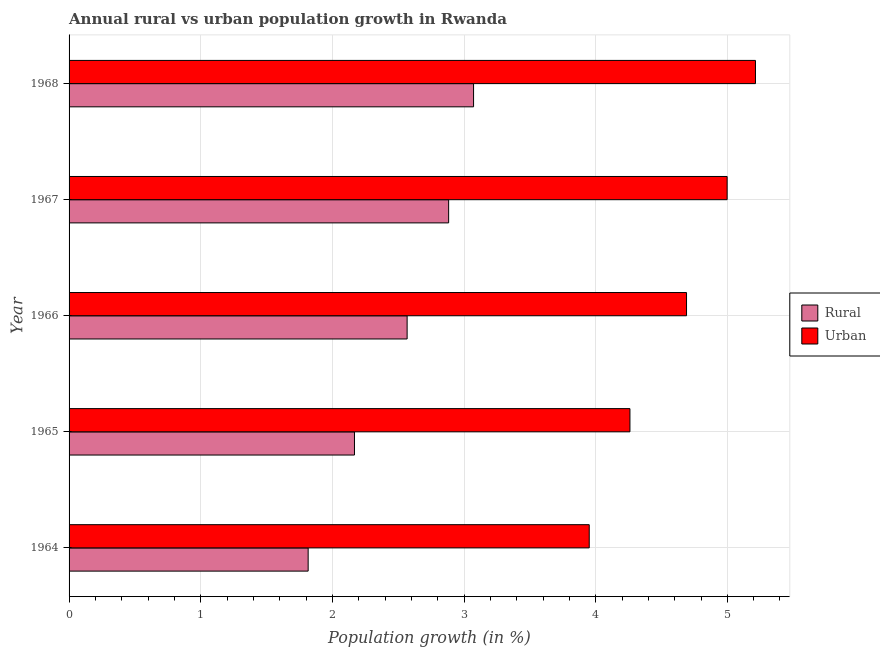Are the number of bars per tick equal to the number of legend labels?
Give a very brief answer. Yes. Are the number of bars on each tick of the Y-axis equal?
Offer a terse response. Yes. What is the label of the 2nd group of bars from the top?
Make the answer very short. 1967. What is the urban population growth in 1966?
Make the answer very short. 4.69. Across all years, what is the maximum rural population growth?
Your response must be concise. 3.07. Across all years, what is the minimum urban population growth?
Offer a terse response. 3.95. In which year was the urban population growth maximum?
Give a very brief answer. 1968. In which year was the urban population growth minimum?
Your response must be concise. 1964. What is the total urban population growth in the graph?
Your answer should be very brief. 23.11. What is the difference between the rural population growth in 1965 and that in 1968?
Ensure brevity in your answer.  -0.91. What is the difference between the urban population growth in 1964 and the rural population growth in 1966?
Your answer should be compact. 1.38. What is the average rural population growth per year?
Make the answer very short. 2.5. In the year 1968, what is the difference between the rural population growth and urban population growth?
Make the answer very short. -2.14. Is the difference between the rural population growth in 1964 and 1967 greater than the difference between the urban population growth in 1964 and 1967?
Provide a succinct answer. No. What is the difference between the highest and the second highest urban population growth?
Keep it short and to the point. 0.21. What is the difference between the highest and the lowest urban population growth?
Provide a succinct answer. 1.26. In how many years, is the rural population growth greater than the average rural population growth taken over all years?
Your answer should be compact. 3. What does the 2nd bar from the top in 1965 represents?
Offer a terse response. Rural. What does the 1st bar from the bottom in 1968 represents?
Keep it short and to the point. Rural. How many bars are there?
Your response must be concise. 10. Are all the bars in the graph horizontal?
Keep it short and to the point. Yes. How many years are there in the graph?
Make the answer very short. 5. Does the graph contain any zero values?
Your answer should be very brief. No. Does the graph contain grids?
Provide a succinct answer. Yes. Where does the legend appear in the graph?
Provide a succinct answer. Center right. What is the title of the graph?
Ensure brevity in your answer.  Annual rural vs urban population growth in Rwanda. Does "Lower secondary education" appear as one of the legend labels in the graph?
Offer a very short reply. No. What is the label or title of the X-axis?
Make the answer very short. Population growth (in %). What is the Population growth (in %) of Rural in 1964?
Provide a short and direct response. 1.82. What is the Population growth (in %) in Urban  in 1964?
Provide a short and direct response. 3.95. What is the Population growth (in %) in Rural in 1965?
Provide a succinct answer. 2.17. What is the Population growth (in %) in Urban  in 1965?
Provide a succinct answer. 4.26. What is the Population growth (in %) in Rural in 1966?
Make the answer very short. 2.57. What is the Population growth (in %) of Urban  in 1966?
Your answer should be very brief. 4.69. What is the Population growth (in %) in Rural in 1967?
Your answer should be very brief. 2.88. What is the Population growth (in %) of Urban  in 1967?
Your answer should be compact. 5. What is the Population growth (in %) of Rural in 1968?
Your response must be concise. 3.07. What is the Population growth (in %) of Urban  in 1968?
Keep it short and to the point. 5.21. Across all years, what is the maximum Population growth (in %) in Rural?
Keep it short and to the point. 3.07. Across all years, what is the maximum Population growth (in %) of Urban ?
Make the answer very short. 5.21. Across all years, what is the minimum Population growth (in %) of Rural?
Offer a terse response. 1.82. Across all years, what is the minimum Population growth (in %) in Urban ?
Offer a terse response. 3.95. What is the total Population growth (in %) in Rural in the graph?
Make the answer very short. 12.51. What is the total Population growth (in %) in Urban  in the graph?
Provide a short and direct response. 23.11. What is the difference between the Population growth (in %) of Rural in 1964 and that in 1965?
Offer a very short reply. -0.35. What is the difference between the Population growth (in %) in Urban  in 1964 and that in 1965?
Keep it short and to the point. -0.31. What is the difference between the Population growth (in %) in Rural in 1964 and that in 1966?
Your answer should be compact. -0.75. What is the difference between the Population growth (in %) of Urban  in 1964 and that in 1966?
Give a very brief answer. -0.74. What is the difference between the Population growth (in %) in Rural in 1964 and that in 1967?
Make the answer very short. -1.07. What is the difference between the Population growth (in %) of Urban  in 1964 and that in 1967?
Make the answer very short. -1.05. What is the difference between the Population growth (in %) of Rural in 1964 and that in 1968?
Your response must be concise. -1.26. What is the difference between the Population growth (in %) of Urban  in 1964 and that in 1968?
Your response must be concise. -1.26. What is the difference between the Population growth (in %) in Urban  in 1965 and that in 1966?
Make the answer very short. -0.43. What is the difference between the Population growth (in %) in Rural in 1965 and that in 1967?
Make the answer very short. -0.72. What is the difference between the Population growth (in %) of Urban  in 1965 and that in 1967?
Your response must be concise. -0.74. What is the difference between the Population growth (in %) of Rural in 1965 and that in 1968?
Your response must be concise. -0.9. What is the difference between the Population growth (in %) of Urban  in 1965 and that in 1968?
Offer a very short reply. -0.95. What is the difference between the Population growth (in %) in Rural in 1966 and that in 1967?
Give a very brief answer. -0.32. What is the difference between the Population growth (in %) of Urban  in 1966 and that in 1967?
Your response must be concise. -0.31. What is the difference between the Population growth (in %) in Rural in 1966 and that in 1968?
Provide a succinct answer. -0.5. What is the difference between the Population growth (in %) of Urban  in 1966 and that in 1968?
Make the answer very short. -0.52. What is the difference between the Population growth (in %) of Rural in 1967 and that in 1968?
Make the answer very short. -0.19. What is the difference between the Population growth (in %) of Urban  in 1967 and that in 1968?
Your answer should be very brief. -0.22. What is the difference between the Population growth (in %) in Rural in 1964 and the Population growth (in %) in Urban  in 1965?
Offer a terse response. -2.44. What is the difference between the Population growth (in %) of Rural in 1964 and the Population growth (in %) of Urban  in 1966?
Make the answer very short. -2.87. What is the difference between the Population growth (in %) in Rural in 1964 and the Population growth (in %) in Urban  in 1967?
Provide a succinct answer. -3.18. What is the difference between the Population growth (in %) of Rural in 1964 and the Population growth (in %) of Urban  in 1968?
Your answer should be very brief. -3.4. What is the difference between the Population growth (in %) of Rural in 1965 and the Population growth (in %) of Urban  in 1966?
Provide a succinct answer. -2.52. What is the difference between the Population growth (in %) of Rural in 1965 and the Population growth (in %) of Urban  in 1967?
Make the answer very short. -2.83. What is the difference between the Population growth (in %) of Rural in 1965 and the Population growth (in %) of Urban  in 1968?
Ensure brevity in your answer.  -3.05. What is the difference between the Population growth (in %) in Rural in 1966 and the Population growth (in %) in Urban  in 1967?
Your response must be concise. -2.43. What is the difference between the Population growth (in %) in Rural in 1966 and the Population growth (in %) in Urban  in 1968?
Offer a terse response. -2.65. What is the difference between the Population growth (in %) in Rural in 1967 and the Population growth (in %) in Urban  in 1968?
Make the answer very short. -2.33. What is the average Population growth (in %) of Rural per year?
Offer a very short reply. 2.5. What is the average Population growth (in %) of Urban  per year?
Provide a short and direct response. 4.62. In the year 1964, what is the difference between the Population growth (in %) of Rural and Population growth (in %) of Urban ?
Your answer should be compact. -2.14. In the year 1965, what is the difference between the Population growth (in %) in Rural and Population growth (in %) in Urban ?
Give a very brief answer. -2.09. In the year 1966, what is the difference between the Population growth (in %) of Rural and Population growth (in %) of Urban ?
Give a very brief answer. -2.12. In the year 1967, what is the difference between the Population growth (in %) in Rural and Population growth (in %) in Urban ?
Give a very brief answer. -2.12. In the year 1968, what is the difference between the Population growth (in %) of Rural and Population growth (in %) of Urban ?
Your answer should be compact. -2.14. What is the ratio of the Population growth (in %) of Rural in 1964 to that in 1965?
Make the answer very short. 0.84. What is the ratio of the Population growth (in %) in Urban  in 1964 to that in 1965?
Give a very brief answer. 0.93. What is the ratio of the Population growth (in %) of Rural in 1964 to that in 1966?
Your response must be concise. 0.71. What is the ratio of the Population growth (in %) of Urban  in 1964 to that in 1966?
Offer a very short reply. 0.84. What is the ratio of the Population growth (in %) in Rural in 1964 to that in 1967?
Give a very brief answer. 0.63. What is the ratio of the Population growth (in %) of Urban  in 1964 to that in 1967?
Provide a succinct answer. 0.79. What is the ratio of the Population growth (in %) in Rural in 1964 to that in 1968?
Your answer should be very brief. 0.59. What is the ratio of the Population growth (in %) of Urban  in 1964 to that in 1968?
Give a very brief answer. 0.76. What is the ratio of the Population growth (in %) in Rural in 1965 to that in 1966?
Provide a succinct answer. 0.84. What is the ratio of the Population growth (in %) in Urban  in 1965 to that in 1966?
Offer a terse response. 0.91. What is the ratio of the Population growth (in %) in Rural in 1965 to that in 1967?
Offer a very short reply. 0.75. What is the ratio of the Population growth (in %) of Urban  in 1965 to that in 1967?
Your answer should be very brief. 0.85. What is the ratio of the Population growth (in %) in Rural in 1965 to that in 1968?
Give a very brief answer. 0.71. What is the ratio of the Population growth (in %) of Urban  in 1965 to that in 1968?
Ensure brevity in your answer.  0.82. What is the ratio of the Population growth (in %) of Rural in 1966 to that in 1967?
Offer a very short reply. 0.89. What is the ratio of the Population growth (in %) of Urban  in 1966 to that in 1967?
Offer a very short reply. 0.94. What is the ratio of the Population growth (in %) in Rural in 1966 to that in 1968?
Your answer should be very brief. 0.84. What is the ratio of the Population growth (in %) of Urban  in 1966 to that in 1968?
Your response must be concise. 0.9. What is the ratio of the Population growth (in %) in Rural in 1967 to that in 1968?
Make the answer very short. 0.94. What is the ratio of the Population growth (in %) in Urban  in 1967 to that in 1968?
Make the answer very short. 0.96. What is the difference between the highest and the second highest Population growth (in %) in Rural?
Your answer should be very brief. 0.19. What is the difference between the highest and the second highest Population growth (in %) of Urban ?
Make the answer very short. 0.22. What is the difference between the highest and the lowest Population growth (in %) of Rural?
Offer a terse response. 1.26. What is the difference between the highest and the lowest Population growth (in %) of Urban ?
Offer a very short reply. 1.26. 